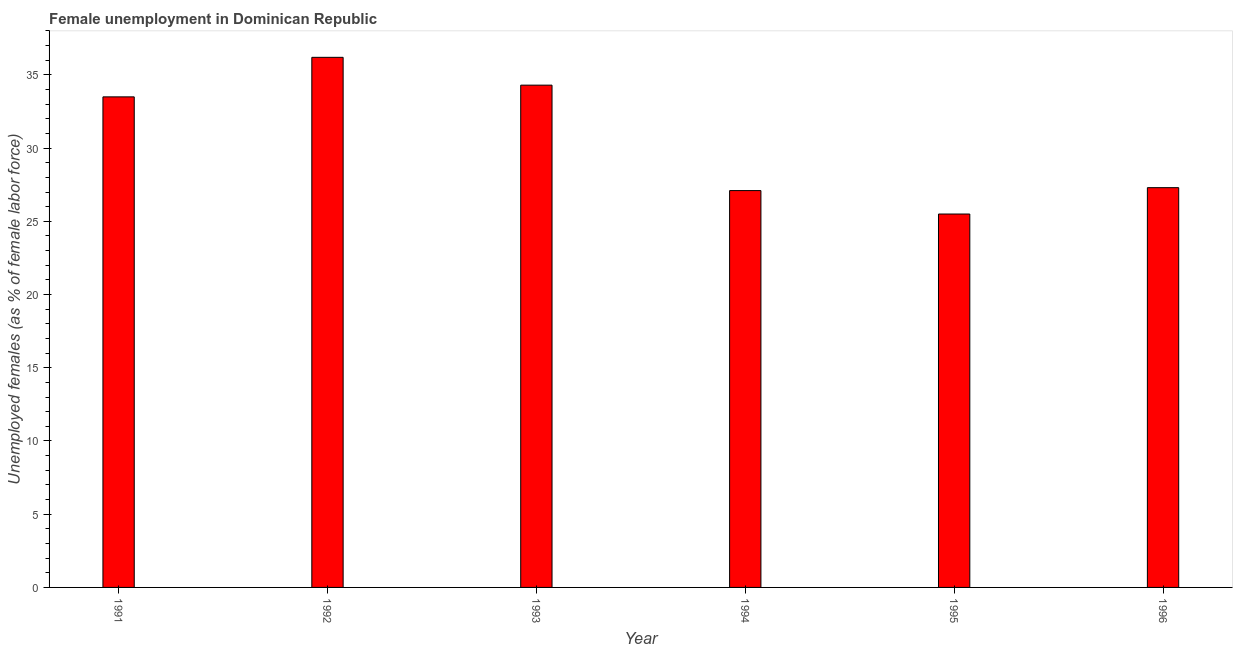Does the graph contain grids?
Make the answer very short. No. What is the title of the graph?
Provide a succinct answer. Female unemployment in Dominican Republic. What is the label or title of the X-axis?
Keep it short and to the point. Year. What is the label or title of the Y-axis?
Give a very brief answer. Unemployed females (as % of female labor force). What is the unemployed females population in 1993?
Provide a short and direct response. 34.3. Across all years, what is the maximum unemployed females population?
Make the answer very short. 36.2. In which year was the unemployed females population minimum?
Ensure brevity in your answer.  1995. What is the sum of the unemployed females population?
Offer a terse response. 183.9. What is the average unemployed females population per year?
Offer a very short reply. 30.65. What is the median unemployed females population?
Your answer should be very brief. 30.4. Do a majority of the years between 1993 and 1995 (inclusive) have unemployed females population greater than 29 %?
Ensure brevity in your answer.  No. What is the ratio of the unemployed females population in 1991 to that in 1996?
Provide a short and direct response. 1.23. What is the difference between the highest and the second highest unemployed females population?
Offer a very short reply. 1.9. Is the sum of the unemployed females population in 1992 and 1994 greater than the maximum unemployed females population across all years?
Your answer should be compact. Yes. What is the difference between the highest and the lowest unemployed females population?
Your response must be concise. 10.7. In how many years, is the unemployed females population greater than the average unemployed females population taken over all years?
Make the answer very short. 3. How many years are there in the graph?
Give a very brief answer. 6. What is the difference between two consecutive major ticks on the Y-axis?
Offer a very short reply. 5. Are the values on the major ticks of Y-axis written in scientific E-notation?
Your answer should be compact. No. What is the Unemployed females (as % of female labor force) in 1991?
Offer a terse response. 33.5. What is the Unemployed females (as % of female labor force) in 1992?
Offer a terse response. 36.2. What is the Unemployed females (as % of female labor force) in 1993?
Make the answer very short. 34.3. What is the Unemployed females (as % of female labor force) of 1994?
Make the answer very short. 27.1. What is the Unemployed females (as % of female labor force) of 1996?
Provide a short and direct response. 27.3. What is the difference between the Unemployed females (as % of female labor force) in 1991 and 1995?
Offer a very short reply. 8. What is the difference between the Unemployed females (as % of female labor force) in 1992 and 1994?
Offer a terse response. 9.1. What is the difference between the Unemployed females (as % of female labor force) in 1992 and 1995?
Offer a very short reply. 10.7. What is the difference between the Unemployed females (as % of female labor force) in 1993 and 1994?
Ensure brevity in your answer.  7.2. What is the difference between the Unemployed females (as % of female labor force) in 1993 and 1995?
Give a very brief answer. 8.8. What is the difference between the Unemployed females (as % of female labor force) in 1993 and 1996?
Keep it short and to the point. 7. What is the difference between the Unemployed females (as % of female labor force) in 1994 and 1995?
Make the answer very short. 1.6. What is the difference between the Unemployed females (as % of female labor force) in 1994 and 1996?
Your answer should be compact. -0.2. What is the difference between the Unemployed females (as % of female labor force) in 1995 and 1996?
Provide a short and direct response. -1.8. What is the ratio of the Unemployed females (as % of female labor force) in 1991 to that in 1992?
Offer a terse response. 0.93. What is the ratio of the Unemployed females (as % of female labor force) in 1991 to that in 1994?
Your response must be concise. 1.24. What is the ratio of the Unemployed females (as % of female labor force) in 1991 to that in 1995?
Provide a succinct answer. 1.31. What is the ratio of the Unemployed females (as % of female labor force) in 1991 to that in 1996?
Your answer should be compact. 1.23. What is the ratio of the Unemployed females (as % of female labor force) in 1992 to that in 1993?
Give a very brief answer. 1.05. What is the ratio of the Unemployed females (as % of female labor force) in 1992 to that in 1994?
Give a very brief answer. 1.34. What is the ratio of the Unemployed females (as % of female labor force) in 1992 to that in 1995?
Offer a terse response. 1.42. What is the ratio of the Unemployed females (as % of female labor force) in 1992 to that in 1996?
Provide a succinct answer. 1.33. What is the ratio of the Unemployed females (as % of female labor force) in 1993 to that in 1994?
Ensure brevity in your answer.  1.27. What is the ratio of the Unemployed females (as % of female labor force) in 1993 to that in 1995?
Your answer should be compact. 1.34. What is the ratio of the Unemployed females (as % of female labor force) in 1993 to that in 1996?
Your answer should be very brief. 1.26. What is the ratio of the Unemployed females (as % of female labor force) in 1994 to that in 1995?
Your answer should be very brief. 1.06. What is the ratio of the Unemployed females (as % of female labor force) in 1994 to that in 1996?
Provide a succinct answer. 0.99. What is the ratio of the Unemployed females (as % of female labor force) in 1995 to that in 1996?
Offer a very short reply. 0.93. 